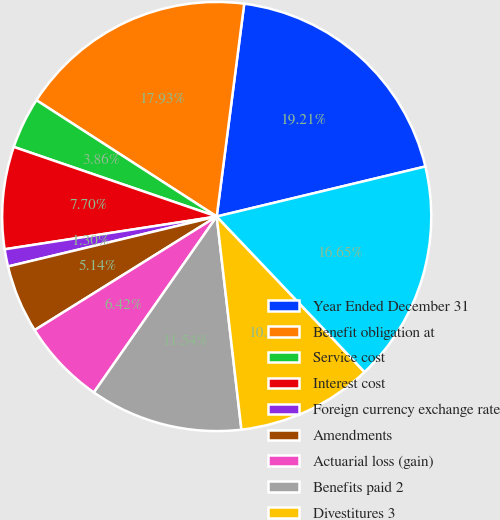<chart> <loc_0><loc_0><loc_500><loc_500><pie_chart><fcel>Year Ended December 31<fcel>Benefit obligation at<fcel>Service cost<fcel>Interest cost<fcel>Foreign currency exchange rate<fcel>Amendments<fcel>Actuarial loss (gain)<fcel>Benefits paid 2<fcel>Divestitures 3<fcel>Benefit obligation at end of<nl><fcel>19.21%<fcel>17.93%<fcel>3.86%<fcel>7.7%<fcel>1.3%<fcel>5.14%<fcel>6.42%<fcel>11.54%<fcel>10.26%<fcel>16.65%<nl></chart> 